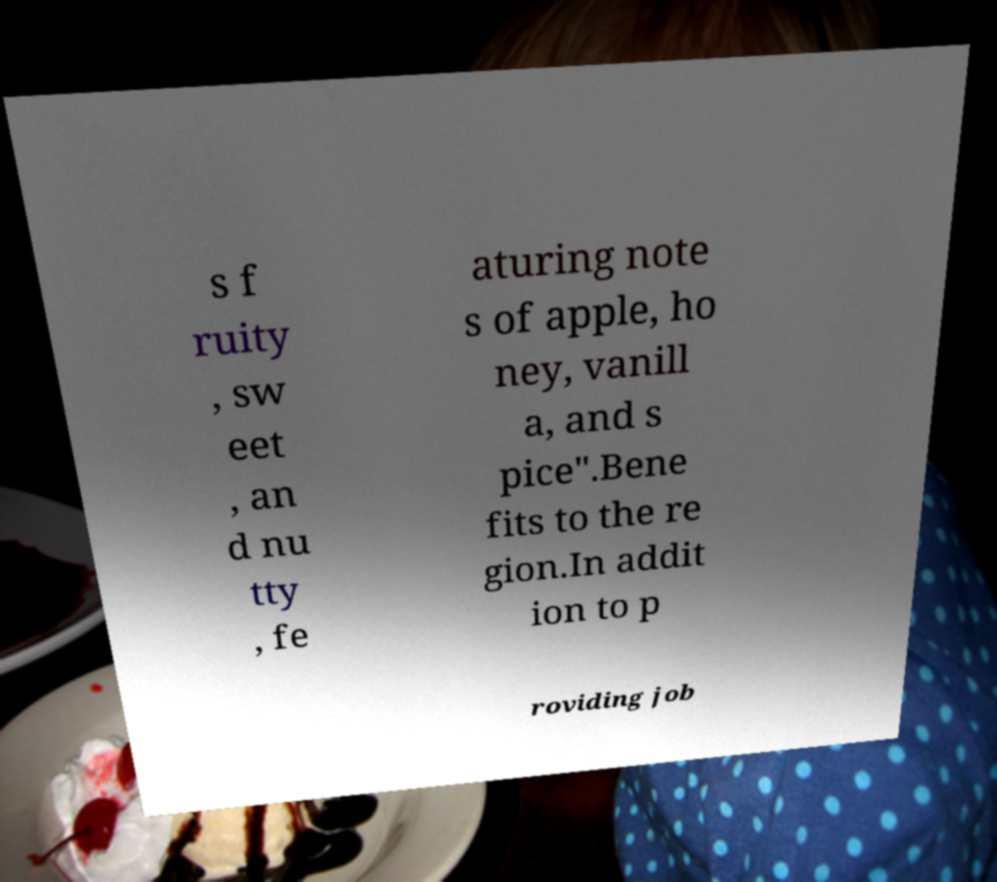Could you assist in decoding the text presented in this image and type it out clearly? s f ruity , sw eet , an d nu tty , fe aturing note s of apple, ho ney, vanill a, and s pice".Bene fits to the re gion.In addit ion to p roviding job 